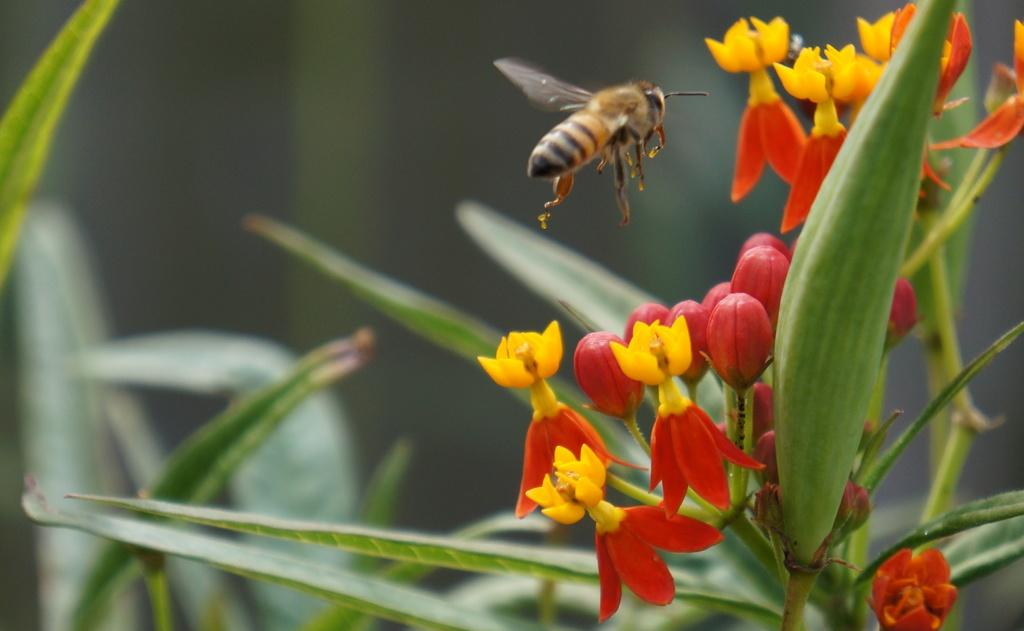What type of insect is present in the image? There is a honey bee in the image. What is the honey bee doing in the image? The honey bee is flying near flowers in the image. What other flora can be seen in the image? There are flowers and plants in the image. How would you describe the background of the image? The background of the image is blurred. What color is the crayon being used to draw on the flowers in the image? There is no crayon present in the image; it features a honey bee flying near flowers. How many cherries are visible on the plants in the image? There are no cherries present in the image; it features flowers and plants. 